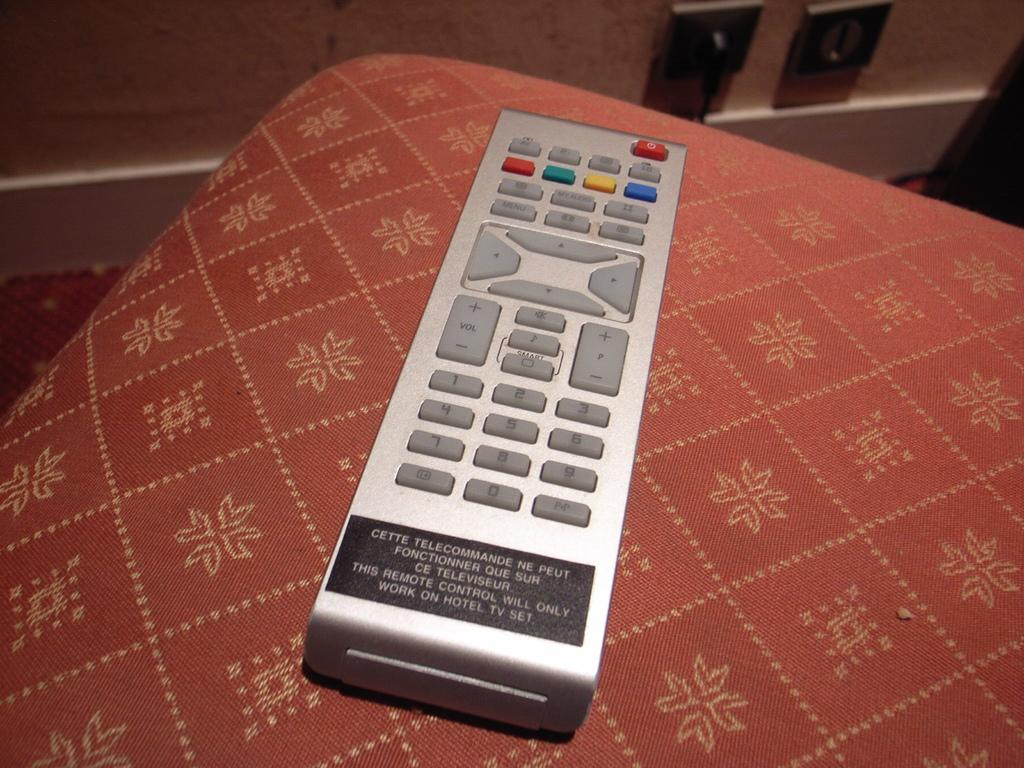<image>
Summarize the visual content of the image. A remote with a button that says Vol on the left side. 